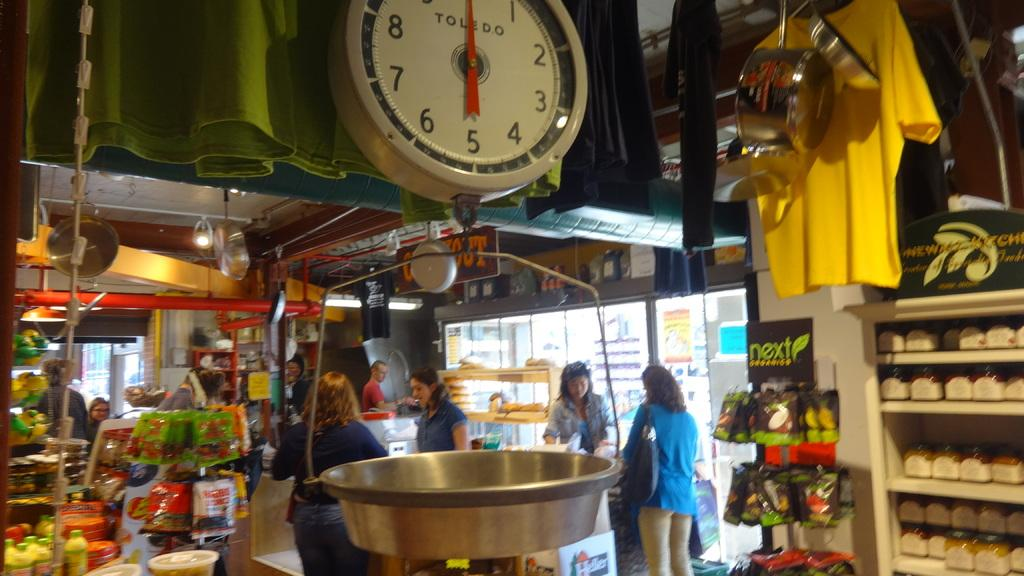<image>
Present a compact description of the photo's key features. A market with a weigh station that has a large white face with Toledo printed on it 